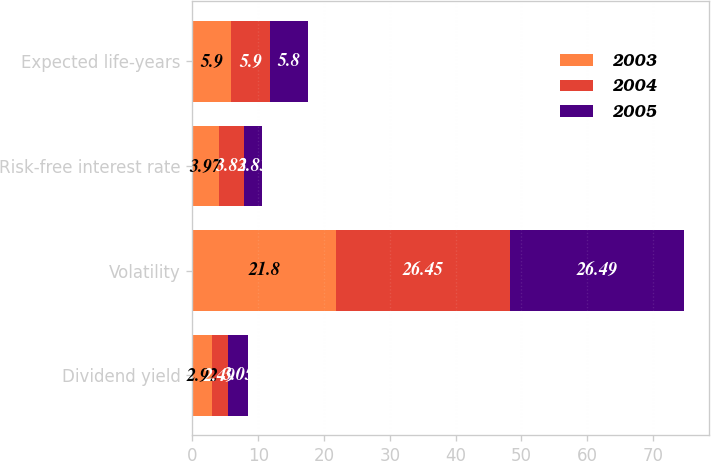Convert chart. <chart><loc_0><loc_0><loc_500><loc_500><stacked_bar_chart><ecel><fcel>Dividend yield<fcel>Volatility<fcel>Risk-free interest rate<fcel>Expected life-years<nl><fcel>2003<fcel>2.92<fcel>21.8<fcel>3.97<fcel>5.9<nl><fcel>2004<fcel>2.49<fcel>26.45<fcel>3.83<fcel>5.9<nl><fcel>2005<fcel>3.05<fcel>26.49<fcel>2.83<fcel>5.8<nl></chart> 